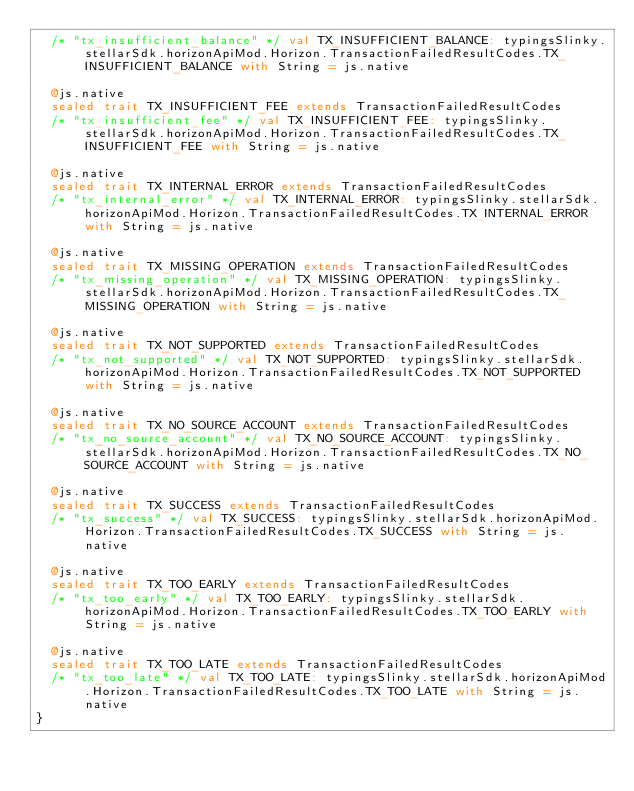<code> <loc_0><loc_0><loc_500><loc_500><_Scala_>  /* "tx_insufficient_balance" */ val TX_INSUFFICIENT_BALANCE: typingsSlinky.stellarSdk.horizonApiMod.Horizon.TransactionFailedResultCodes.TX_INSUFFICIENT_BALANCE with String = js.native
  
  @js.native
  sealed trait TX_INSUFFICIENT_FEE extends TransactionFailedResultCodes
  /* "tx_insufficient_fee" */ val TX_INSUFFICIENT_FEE: typingsSlinky.stellarSdk.horizonApiMod.Horizon.TransactionFailedResultCodes.TX_INSUFFICIENT_FEE with String = js.native
  
  @js.native
  sealed trait TX_INTERNAL_ERROR extends TransactionFailedResultCodes
  /* "tx_internal_error" */ val TX_INTERNAL_ERROR: typingsSlinky.stellarSdk.horizonApiMod.Horizon.TransactionFailedResultCodes.TX_INTERNAL_ERROR with String = js.native
  
  @js.native
  sealed trait TX_MISSING_OPERATION extends TransactionFailedResultCodes
  /* "tx_missing_operation" */ val TX_MISSING_OPERATION: typingsSlinky.stellarSdk.horizonApiMod.Horizon.TransactionFailedResultCodes.TX_MISSING_OPERATION with String = js.native
  
  @js.native
  sealed trait TX_NOT_SUPPORTED extends TransactionFailedResultCodes
  /* "tx_not_supported" */ val TX_NOT_SUPPORTED: typingsSlinky.stellarSdk.horizonApiMod.Horizon.TransactionFailedResultCodes.TX_NOT_SUPPORTED with String = js.native
  
  @js.native
  sealed trait TX_NO_SOURCE_ACCOUNT extends TransactionFailedResultCodes
  /* "tx_no_source_account" */ val TX_NO_SOURCE_ACCOUNT: typingsSlinky.stellarSdk.horizonApiMod.Horizon.TransactionFailedResultCodes.TX_NO_SOURCE_ACCOUNT with String = js.native
  
  @js.native
  sealed trait TX_SUCCESS extends TransactionFailedResultCodes
  /* "tx_success" */ val TX_SUCCESS: typingsSlinky.stellarSdk.horizonApiMod.Horizon.TransactionFailedResultCodes.TX_SUCCESS with String = js.native
  
  @js.native
  sealed trait TX_TOO_EARLY extends TransactionFailedResultCodes
  /* "tx_too_early" */ val TX_TOO_EARLY: typingsSlinky.stellarSdk.horizonApiMod.Horizon.TransactionFailedResultCodes.TX_TOO_EARLY with String = js.native
  
  @js.native
  sealed trait TX_TOO_LATE extends TransactionFailedResultCodes
  /* "tx_too_late" */ val TX_TOO_LATE: typingsSlinky.stellarSdk.horizonApiMod.Horizon.TransactionFailedResultCodes.TX_TOO_LATE with String = js.native
}
</code> 